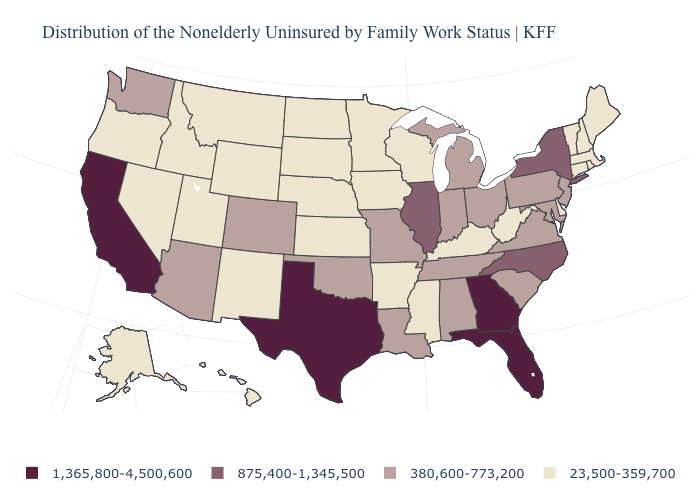Name the states that have a value in the range 380,600-773,200?
Keep it brief. Alabama, Arizona, Colorado, Indiana, Louisiana, Maryland, Michigan, Missouri, New Jersey, Ohio, Oklahoma, Pennsylvania, South Carolina, Tennessee, Virginia, Washington. Does the first symbol in the legend represent the smallest category?
Concise answer only. No. Among the states that border Pennsylvania , does New York have the lowest value?
Concise answer only. No. Which states have the lowest value in the USA?
Keep it brief. Alaska, Arkansas, Connecticut, Delaware, Hawaii, Idaho, Iowa, Kansas, Kentucky, Maine, Massachusetts, Minnesota, Mississippi, Montana, Nebraska, Nevada, New Hampshire, New Mexico, North Dakota, Oregon, Rhode Island, South Dakota, Utah, Vermont, West Virginia, Wisconsin, Wyoming. Is the legend a continuous bar?
Answer briefly. No. Which states have the highest value in the USA?
Give a very brief answer. California, Florida, Georgia, Texas. What is the value of Montana?
Concise answer only. 23,500-359,700. What is the value of Kansas?
Answer briefly. 23,500-359,700. Name the states that have a value in the range 875,400-1,345,500?
Be succinct. Illinois, New York, North Carolina. Does the first symbol in the legend represent the smallest category?
Quick response, please. No. Does the map have missing data?
Concise answer only. No. Among the states that border Kentucky , does West Virginia have the lowest value?
Give a very brief answer. Yes. What is the value of Michigan?
Give a very brief answer. 380,600-773,200. What is the value of South Carolina?
Short answer required. 380,600-773,200. Name the states that have a value in the range 380,600-773,200?
Short answer required. Alabama, Arizona, Colorado, Indiana, Louisiana, Maryland, Michigan, Missouri, New Jersey, Ohio, Oklahoma, Pennsylvania, South Carolina, Tennessee, Virginia, Washington. 